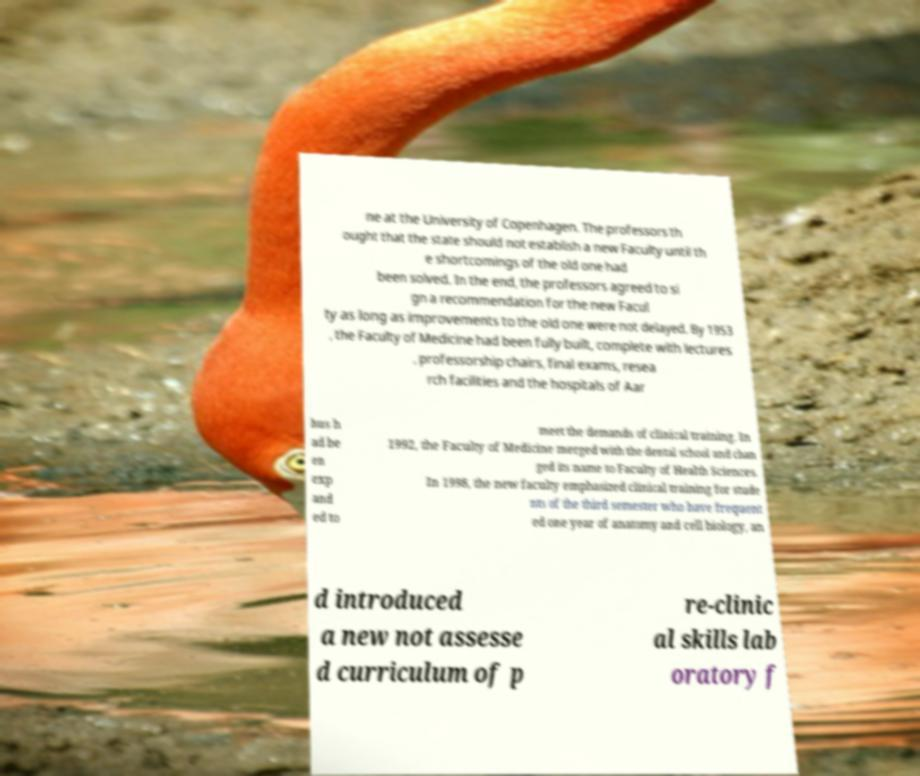I need the written content from this picture converted into text. Can you do that? ne at the University of Copenhagen. The professors th ought that the state should not establish a new Faculty until th e shortcomings of the old one had been solved. In the end, the professors agreed to si gn a recommendation for the new Facul ty as long as improvements to the old one were not delayed. By 1953 , the Faculty of Medicine had been fully built, complete with lectures , professorship chairs, final exams, resea rch facilities and the hospitals of Aar hus h ad be en exp and ed to meet the demands of clinical training. In 1992, the Faculty of Medicine merged with the dental school and chan ged its name to Faculty of Health Sciences. In 1998, the new faculty emphasized clinical training for stude nts of the third semester who have frequent ed one year of anatomy and cell biology, an d introduced a new not assesse d curriculum of p re-clinic al skills lab oratory f 